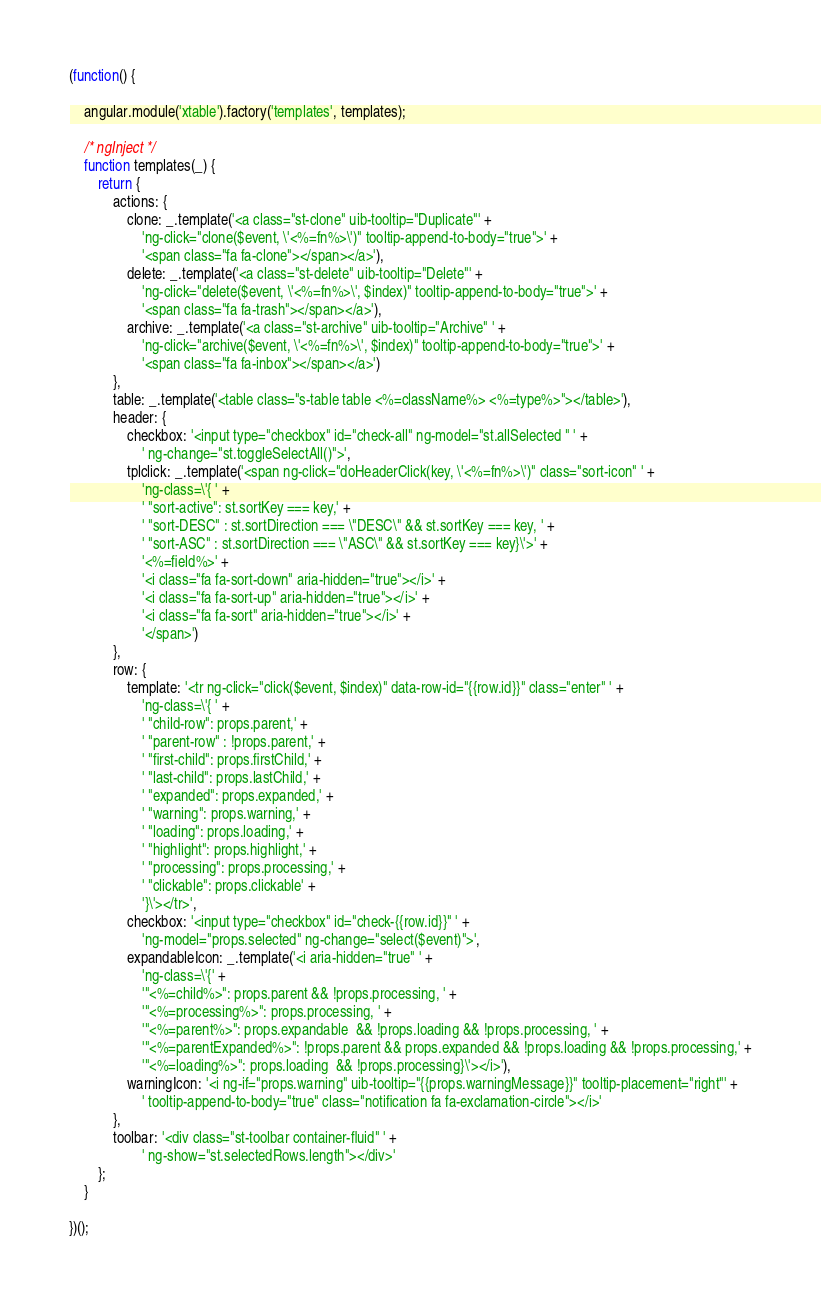Convert code to text. <code><loc_0><loc_0><loc_500><loc_500><_JavaScript_>(function() {

    angular.module('xtable').factory('templates', templates);

    /* ngInject */
    function templates(_) {
        return {
            actions: {
                clone: _.template('<a class="st-clone" uib-tooltip="Duplicate"' +
                    'ng-click="clone($event, \'<%=fn%>\')" tooltip-append-to-body="true">' +
                    '<span class="fa fa-clone"></span></a>'),
                delete: _.template('<a class="st-delete" uib-tooltip="Delete"' +
                    'ng-click="delete($event, \'<%=fn%>\', $index)" tooltip-append-to-body="true">' +
                    '<span class="fa fa-trash"></span></a>'),
                archive: _.template('<a class="st-archive" uib-tooltip="Archive" ' +
                    'ng-click="archive($event, \'<%=fn%>\', $index)" tooltip-append-to-body="true">' +
                    '<span class="fa fa-inbox"></span></a>')
            },
            table: _.template('<table class="s-table table <%=className%> <%=type%>"></table>'),
            header: {
                checkbox: '<input type="checkbox" id="check-all" ng-model="st.allSelected " ' +
                    ' ng-change="st.toggleSelectAll()">',
                tplclick: _.template('<span ng-click="doHeaderClick(key, \'<%=fn%>\')" class="sort-icon" ' +
                    'ng-class=\'{ ' +
                    ' "sort-active": st.sortKey === key,' +
                    ' "sort-DESC" : st.sortDirection === \"DESC\" && st.sortKey === key, ' +
                    ' "sort-ASC" : st.sortDirection === \"ASC\" && st.sortKey === key}\'>' +
                    '<%=field%>' +
                    '<i class="fa fa-sort-down" aria-hidden="true"></i>' +
                    '<i class="fa fa-sort-up" aria-hidden="true"></i>' +
                    '<i class="fa fa-sort" aria-hidden="true"></i>' +
                    '</span>')
            },
            row: {
                template: '<tr ng-click="click($event, $index)" data-row-id="{{row.id}}" class="enter" ' +
                    'ng-class=\'{ ' +
                    ' "child-row": props.parent,' +
                    ' "parent-row" : !props.parent,' +
                    ' "first-child": props.firstChild,' +
                    ' "last-child": props.lastChild,' +
                    ' "expanded": props.expanded,' +
                    ' "warning": props.warning,' +
                    ' "loading": props.loading,' +
                    ' "highlight": props.highlight,' +
                    ' "processing": props.processing,' +
                    ' "clickable": props.clickable' +
                    '}\'></tr>',
                checkbox: '<input type="checkbox" id="check-{{row.id}}" ' +
                    'ng-model="props.selected" ng-change="select($event)">',
                expandableIcon: _.template('<i aria-hidden="true" ' +
                    'ng-class=\'{' +
                    '"<%=child%>": props.parent && !props.processing, ' +
                    '"<%=processing%>": props.processing, ' +
                    '"<%=parent%>": props.expandable  && !props.loading && !props.processing, ' +
                    '"<%=parentExpanded%>": !props.parent && props.expanded && !props.loading && !props.processing,' +
                    '"<%=loading%>": props.loading  && !props.processing}\'></i>'),
                warningIcon: '<i ng-if="props.warning" uib-tooltip="{{props.warningMessage}}" tooltip-placement="right"' +
                    ' tooltip-append-to-body="true" class="notification fa fa-exclamation-circle"></i>'
            },
            toolbar: '<div class="st-toolbar container-fluid" ' +
                    ' ng-show="st.selectedRows.length"></div>'
        };
    }

})();
</code> 